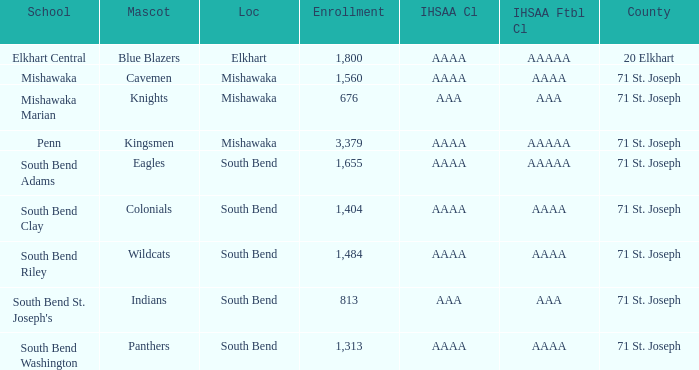What IHSAA Football Class has 20 elkhart as the county? AAAAA. 